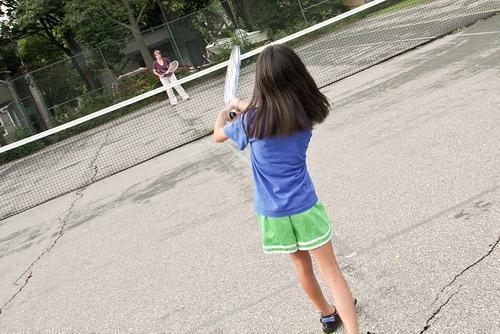How many people are in this photo?
Give a very brief answer. 2. 